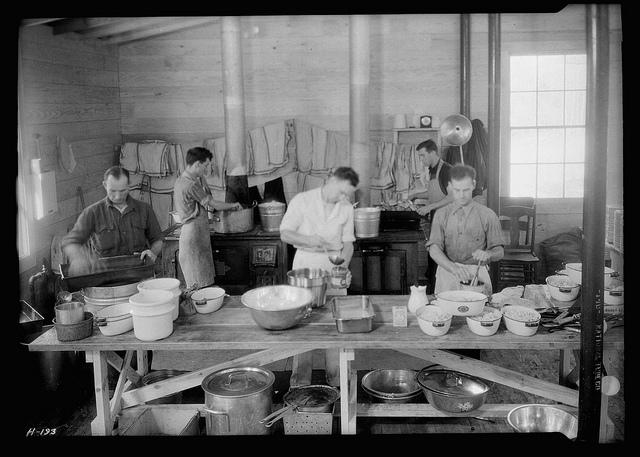What is on display?
Be succinct. Cooking. Are these stuffed animals inside?
Keep it brief. No. Do these people look busy cooking?
Quick response, please. Yes. What is on the ground?
Be succinct. Dishes. How many men are there?
Concise answer only. 5. What kind of establishment is this?
Short answer required. Kitchen. Are there any women in the picture?
Be succinct. No. 